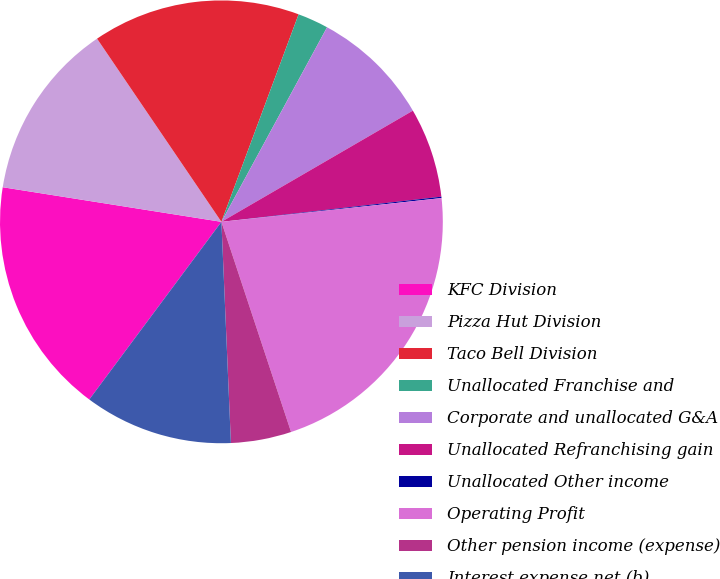<chart> <loc_0><loc_0><loc_500><loc_500><pie_chart><fcel>KFC Division<fcel>Pizza Hut Division<fcel>Taco Bell Division<fcel>Unallocated Franchise and<fcel>Corporate and unallocated G&A<fcel>Unallocated Refranchising gain<fcel>Unallocated Other income<fcel>Operating Profit<fcel>Other pension income (expense)<fcel>Interest expense net (b)<nl><fcel>17.32%<fcel>13.01%<fcel>15.16%<fcel>2.25%<fcel>8.71%<fcel>6.56%<fcel>0.1%<fcel>21.62%<fcel>4.41%<fcel>10.86%<nl></chart> 